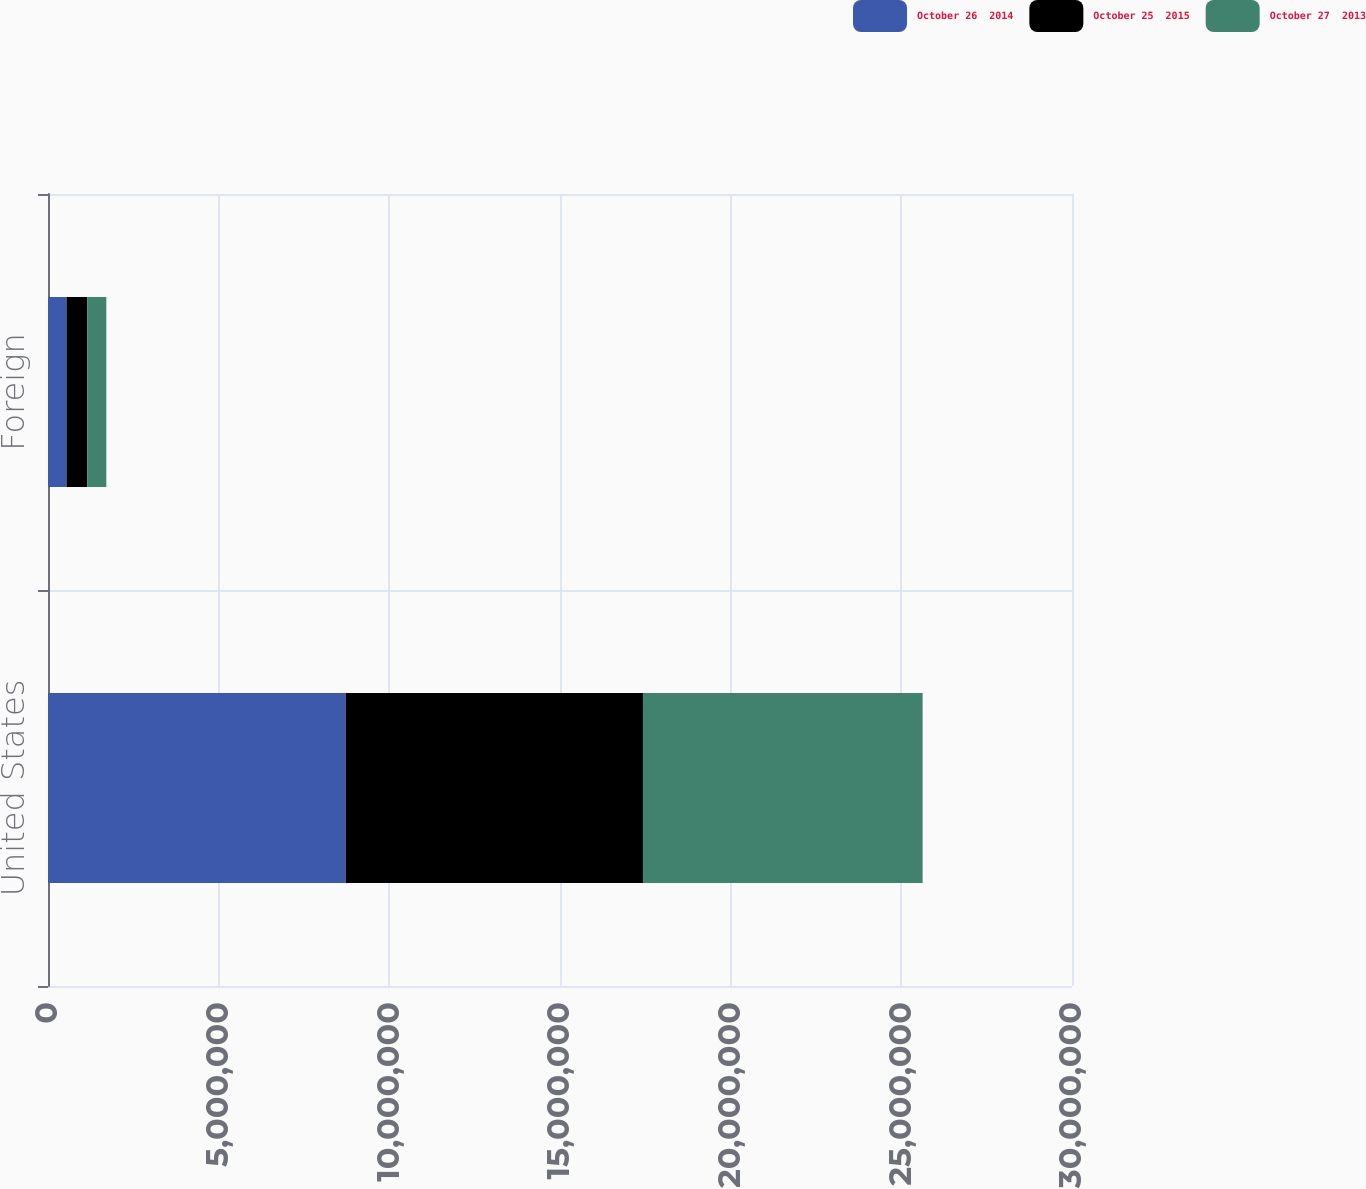Convert chart. <chart><loc_0><loc_0><loc_500><loc_500><stacked_bar_chart><ecel><fcel>United States<fcel>Foreign<nl><fcel>October 26  2014<fcel>8.72172e+06<fcel>542141<nl><fcel>October 25  2015<fcel>8.70804e+06<fcel>608214<nl><fcel>October 27  2013<fcel>8.19373e+06<fcel>557924<nl></chart> 